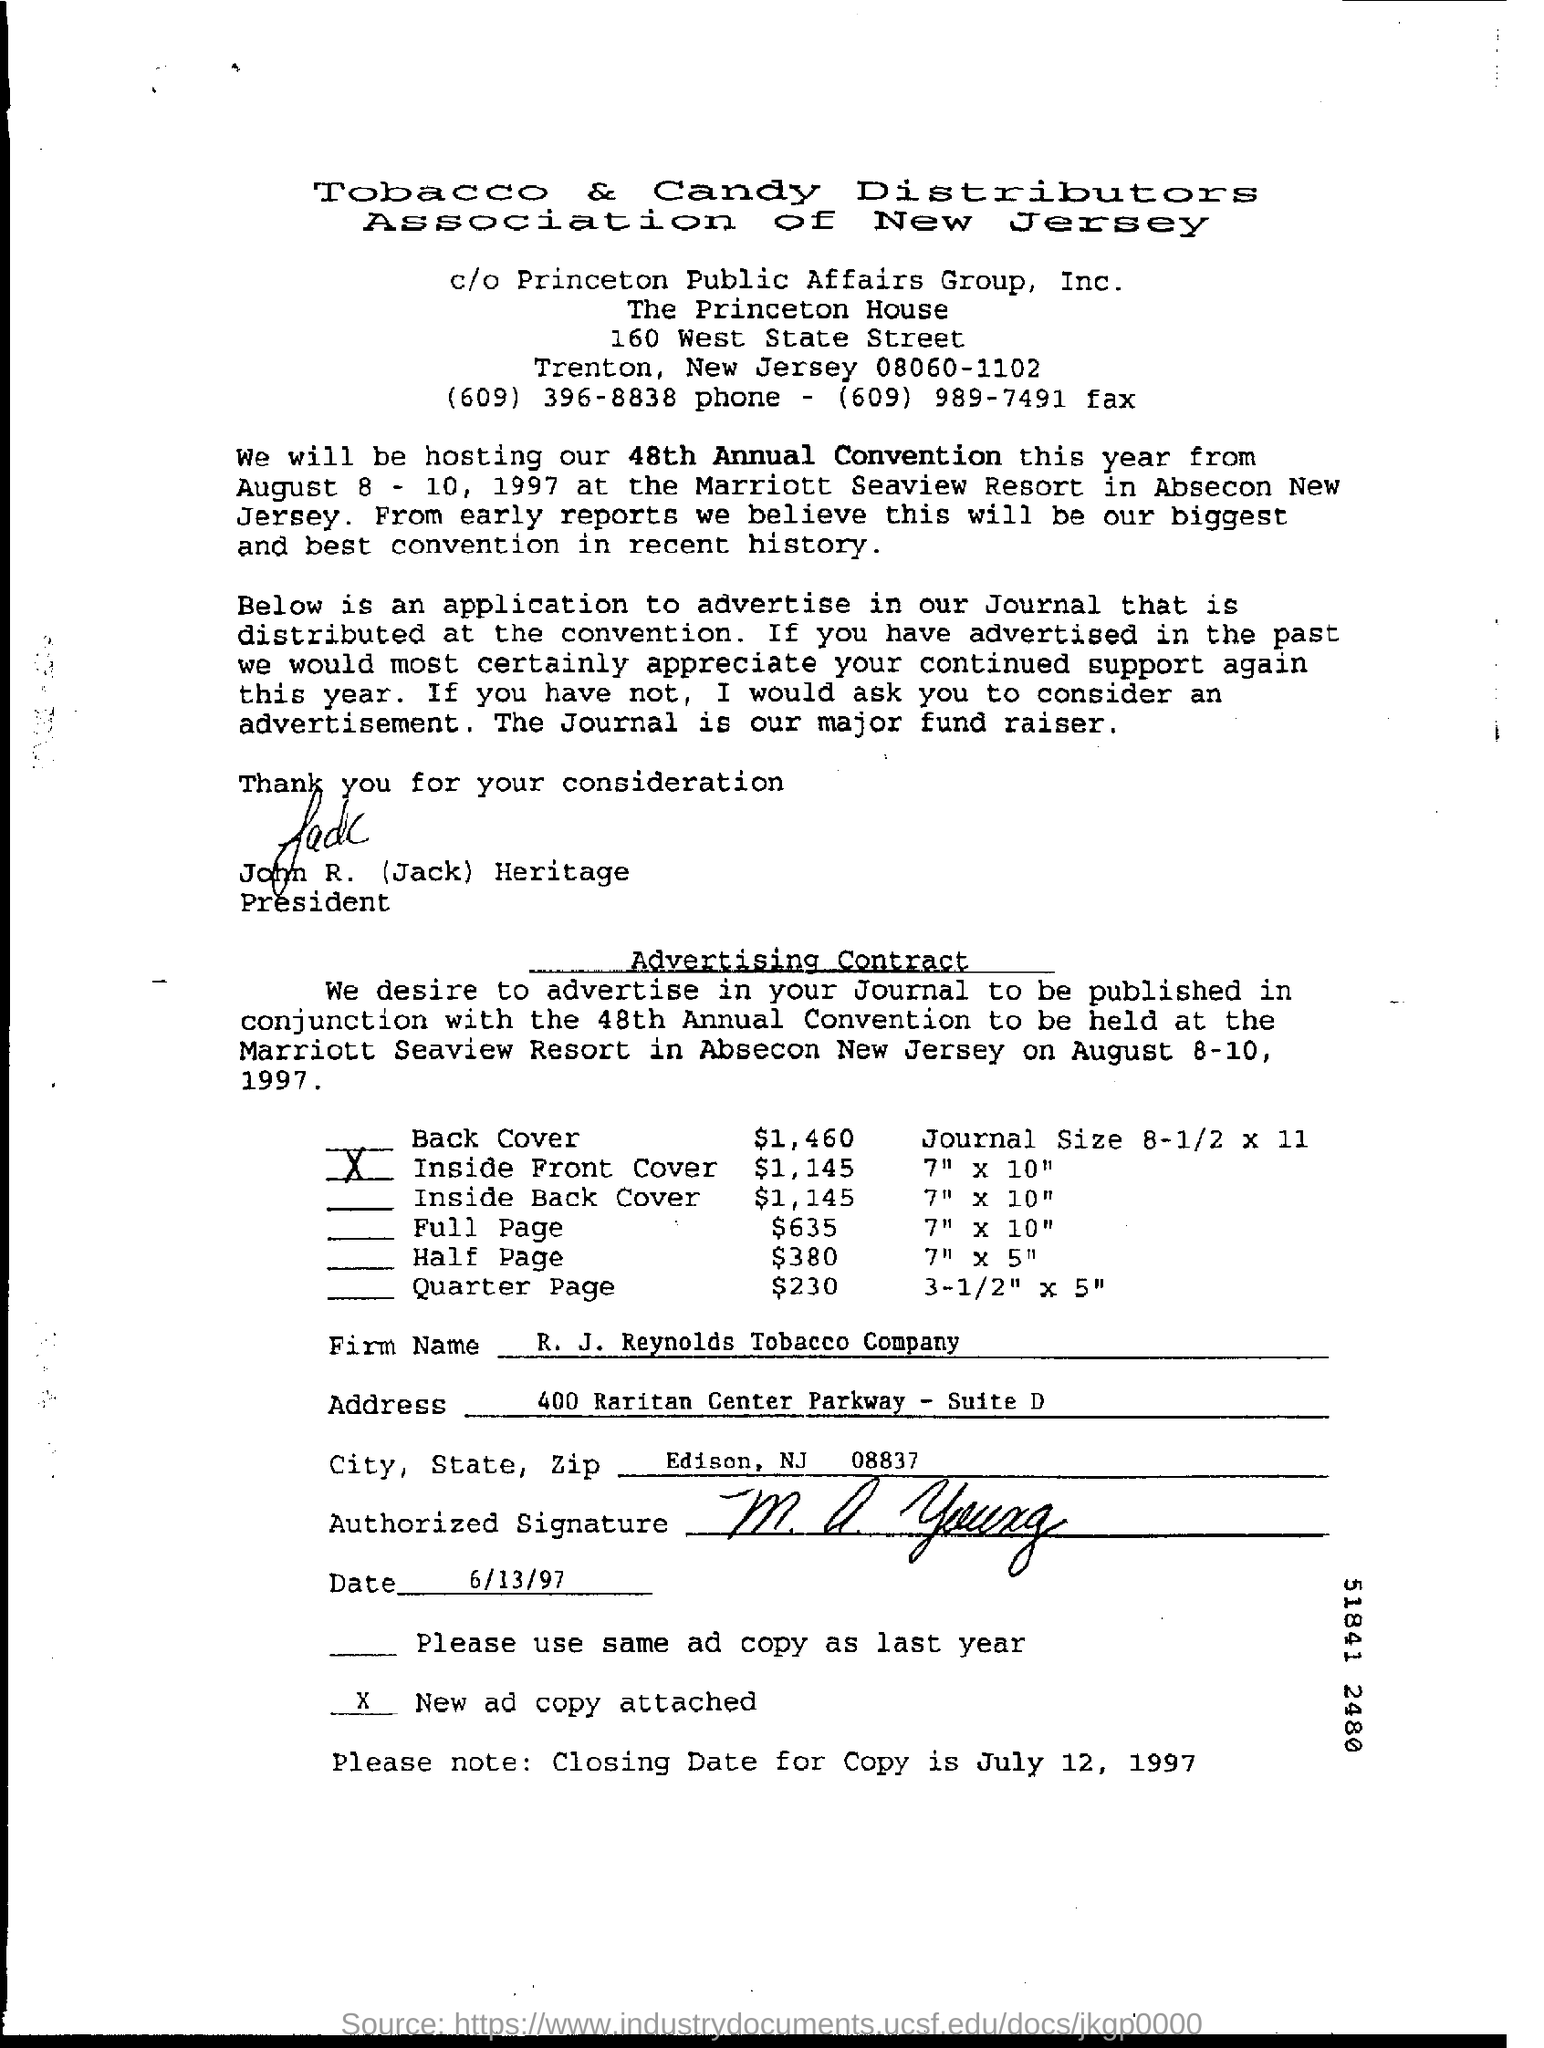What is the Firm Name?
Your answer should be compact. R. J. Reynolds Tobacco Company. What is the Closing date for Copy?
Make the answer very short. July 12 , 1997. 